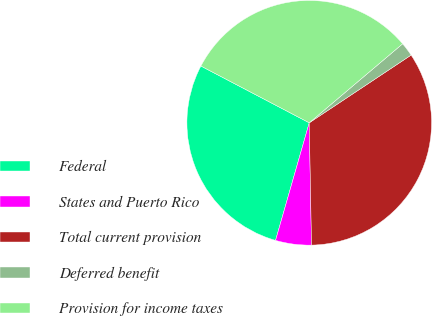Convert chart. <chart><loc_0><loc_0><loc_500><loc_500><pie_chart><fcel>Federal<fcel>States and Puerto Rico<fcel>Total current provision<fcel>Deferred benefit<fcel>Provision for income taxes<nl><fcel>28.24%<fcel>4.74%<fcel>34.04%<fcel>1.84%<fcel>31.14%<nl></chart> 